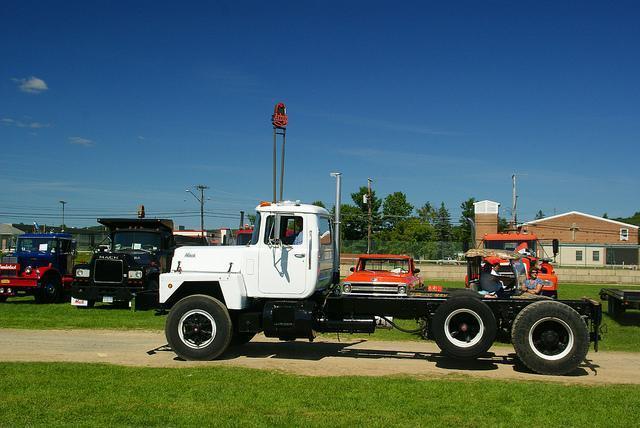How many tires are on the truck?
Give a very brief answer. 6. How many trucks are visible?
Give a very brief answer. 4. 